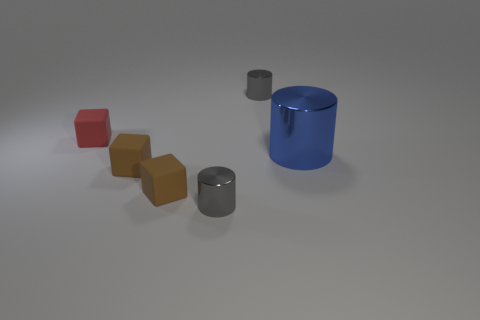Add 1 small cubes. How many objects exist? 7 Add 5 small metal things. How many small metal things exist? 7 Subtract 0 red balls. How many objects are left? 6 Subtract all tiny metallic things. Subtract all red objects. How many objects are left? 3 Add 1 gray metal things. How many gray metal things are left? 3 